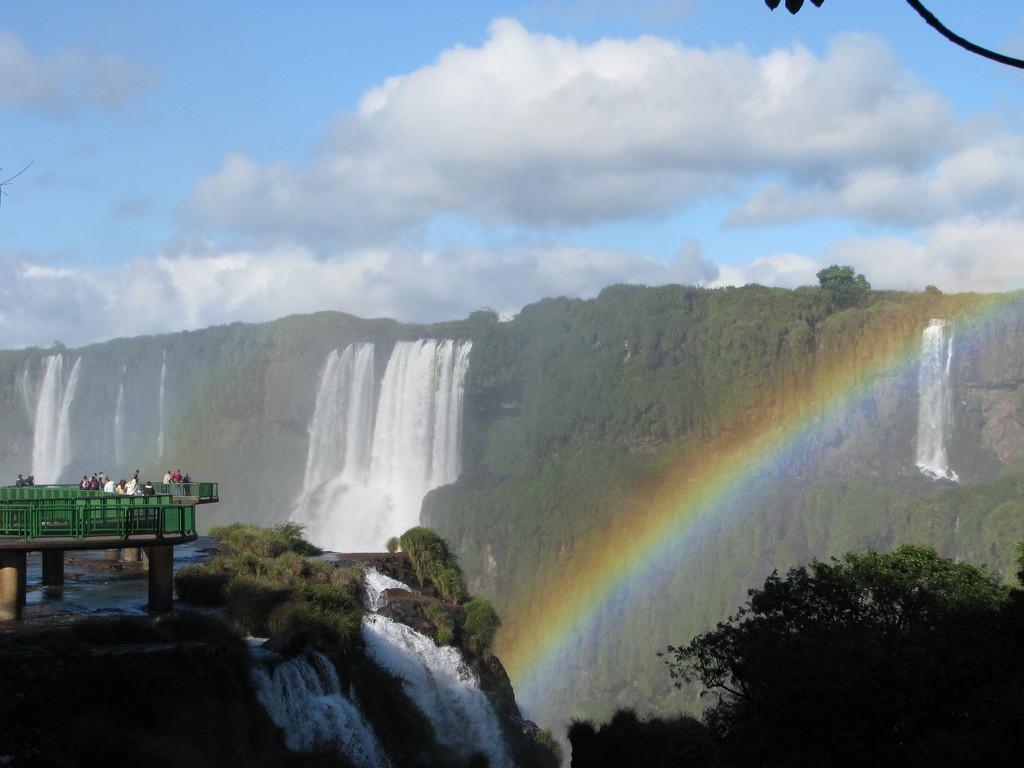Could you give a brief overview of what you see in this image? To the left side of the image there is a bridge with few people are standing. Below the bridge there is a hill with water flow. To the right bottom of the image there is a tree. And to the top of the image there are hills with waterfalls. To the top of the image there is a sky. 